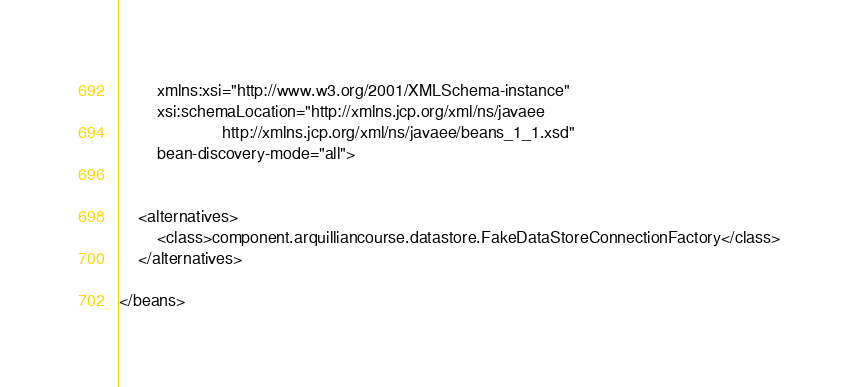<code> <loc_0><loc_0><loc_500><loc_500><_XML_>        xmlns:xsi="http://www.w3.org/2001/XMLSchema-instance"
        xsi:schemaLocation="http://xmlns.jcp.org/xml/ns/javaee 
                      http://xmlns.jcp.org/xml/ns/javaee/beans_1_1.xsd"
        bean-discovery-mode="all">


    <alternatives>
        <class>component.arquilliancourse.datastore.FakeDataStoreConnectionFactory</class>
    </alternatives>

</beans></code> 